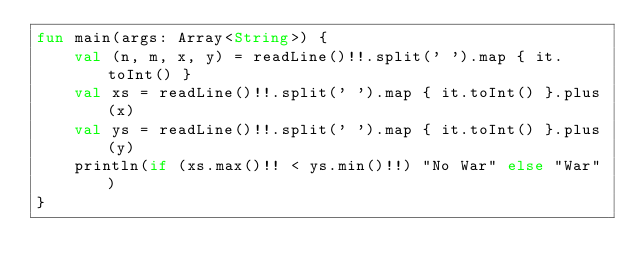<code> <loc_0><loc_0><loc_500><loc_500><_Kotlin_>fun main(args: Array<String>) {
    val (n, m, x, y) = readLine()!!.split(' ').map { it.toInt() }
    val xs = readLine()!!.split(' ').map { it.toInt() }.plus(x)
    val ys = readLine()!!.split(' ').map { it.toInt() }.plus(y)
    println(if (xs.max()!! < ys.min()!!) "No War" else "War")
}
</code> 